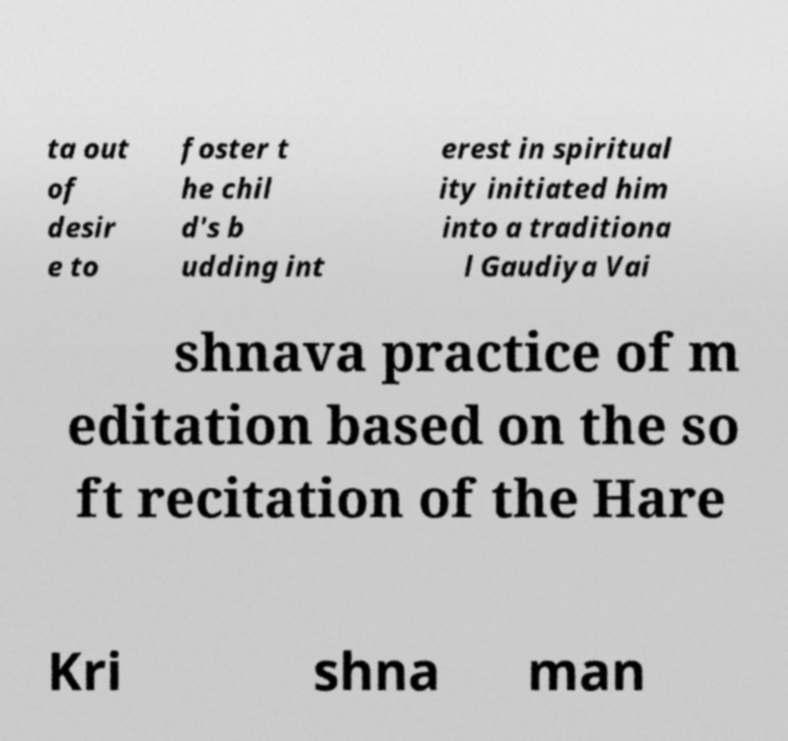Can you read and provide the text displayed in the image?This photo seems to have some interesting text. Can you extract and type it out for me? ta out of desir e to foster t he chil d's b udding int erest in spiritual ity initiated him into a traditiona l Gaudiya Vai shnava practice of m editation based on the so ft recitation of the Hare Kri shna man 